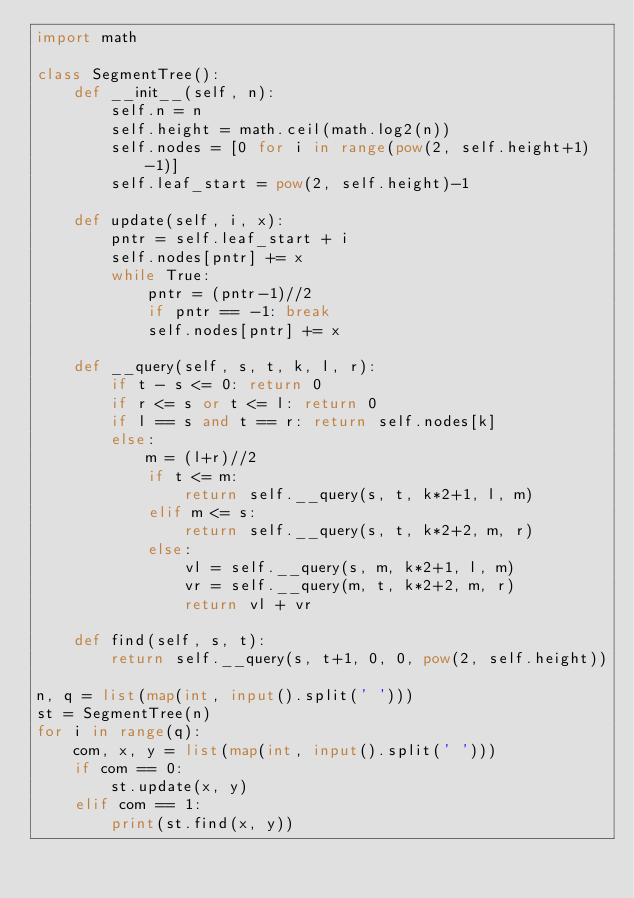Convert code to text. <code><loc_0><loc_0><loc_500><loc_500><_Python_>import math

class SegmentTree():
    def __init__(self, n):
        self.n = n
        self.height = math.ceil(math.log2(n))
        self.nodes = [0 for i in range(pow(2, self.height+1)-1)]
        self.leaf_start = pow(2, self.height)-1

    def update(self, i, x):
        pntr = self.leaf_start + i
        self.nodes[pntr] += x
        while True:
            pntr = (pntr-1)//2
            if pntr == -1: break
            self.nodes[pntr] += x

    def __query(self, s, t, k, l, r):
        if t - s <= 0: return 0
        if r <= s or t <= l: return 0
        if l == s and t == r: return self.nodes[k]
        else:
            m = (l+r)//2
            if t <= m:
                return self.__query(s, t, k*2+1, l, m)
            elif m <= s:
                return self.__query(s, t, k*2+2, m, r)
            else:
                vl = self.__query(s, m, k*2+1, l, m)
                vr = self.__query(m, t, k*2+2, m, r)
                return vl + vr

    def find(self, s, t):
        return self.__query(s, t+1, 0, 0, pow(2, self.height))

n, q = list(map(int, input().split(' ')))
st = SegmentTree(n)
for i in range(q):
    com, x, y = list(map(int, input().split(' ')))
    if com == 0:
        st.update(x, y)
    elif com == 1:
        print(st.find(x, y))


</code> 